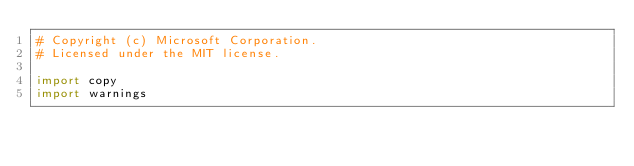Convert code to text. <code><loc_0><loc_0><loc_500><loc_500><_Python_># Copyright (c) Microsoft Corporation.
# Licensed under the MIT license.

import copy
import warnings</code> 